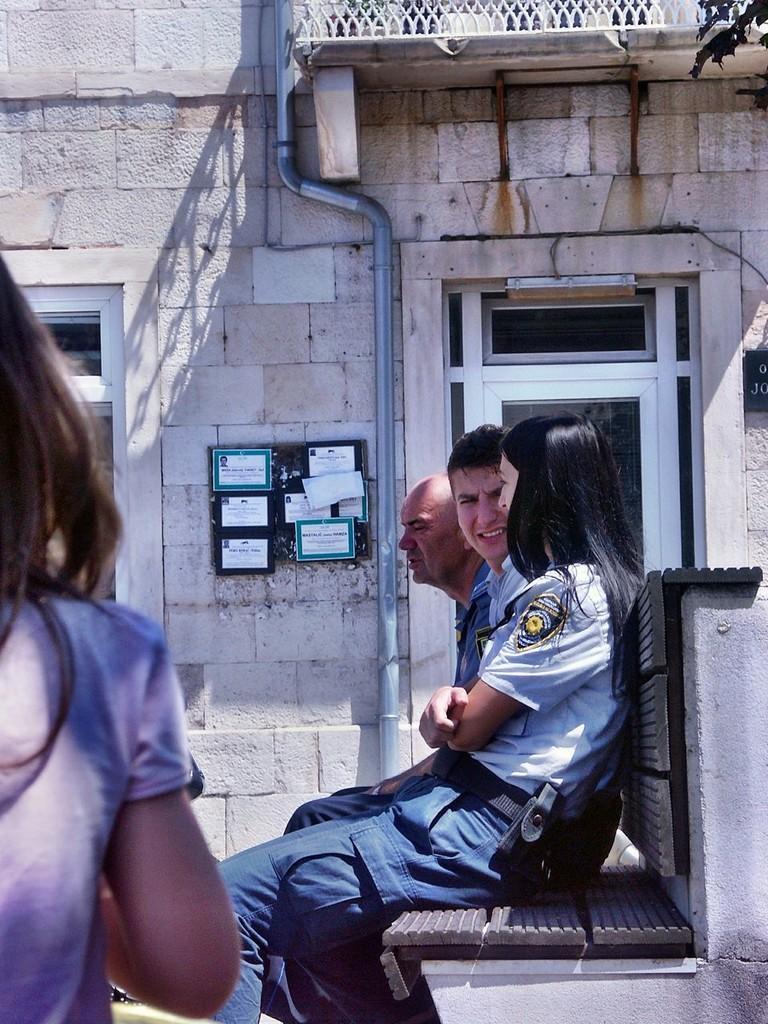Can you describe this image briefly? In the foreground of this image, on the left, there is a person. In the middle, there are three people sitting on a bench. In the background, there is a door, pipe, wall, posters on the wall and it seems like a window on the left. 